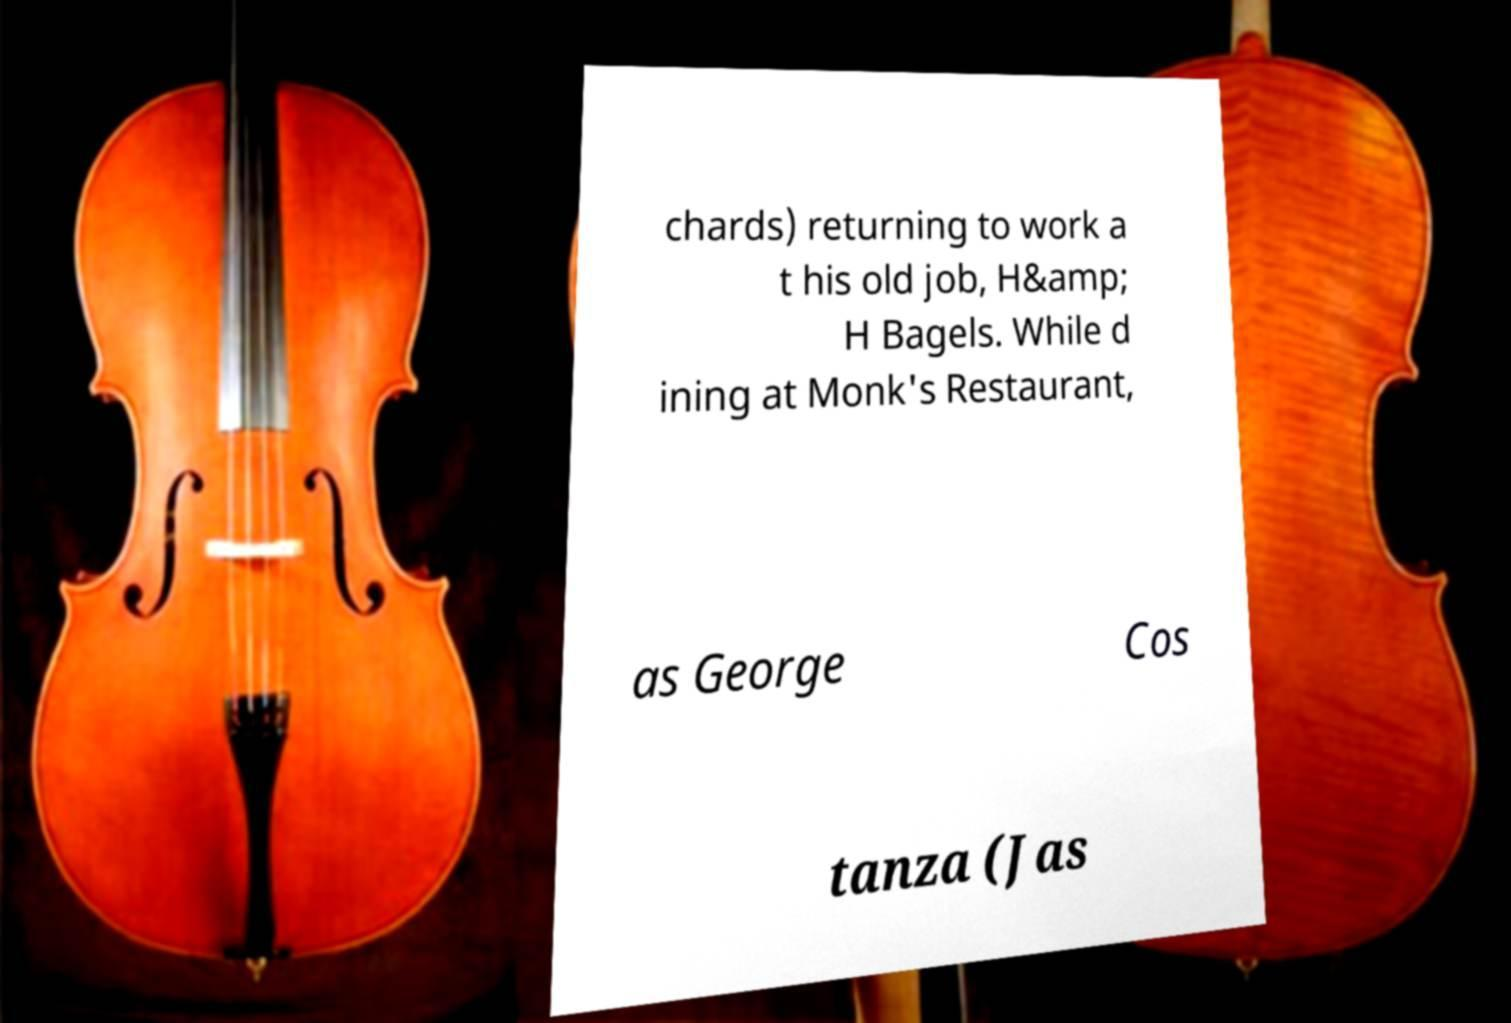For documentation purposes, I need the text within this image transcribed. Could you provide that? chards) returning to work a t his old job, H&amp; H Bagels. While d ining at Monk's Restaurant, as George Cos tanza (Jas 